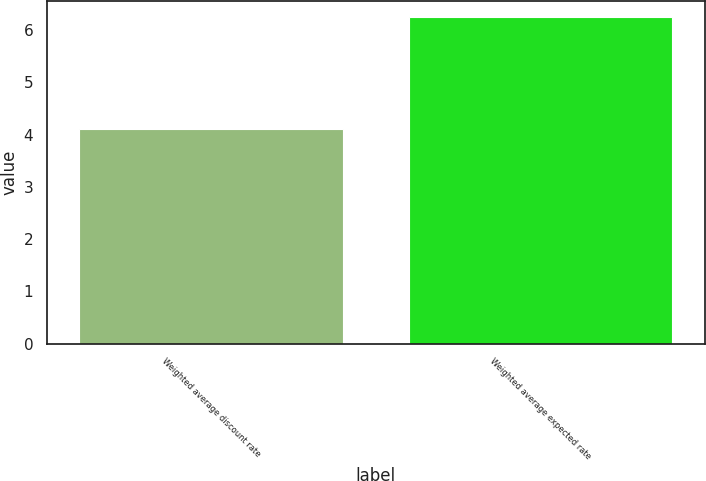Convert chart to OTSL. <chart><loc_0><loc_0><loc_500><loc_500><bar_chart><fcel>Weighted average discount rate<fcel>Weighted average expected rate<nl><fcel>4.1<fcel>6.25<nl></chart> 